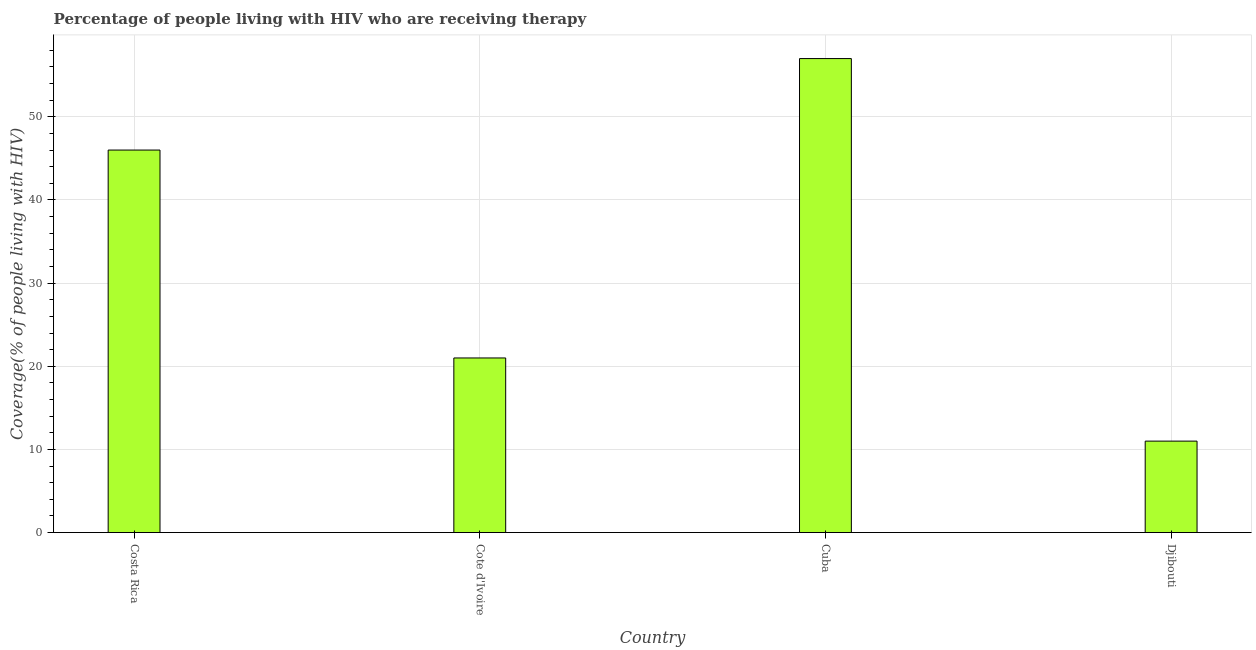Does the graph contain any zero values?
Give a very brief answer. No. Does the graph contain grids?
Your response must be concise. Yes. What is the title of the graph?
Keep it short and to the point. Percentage of people living with HIV who are receiving therapy. What is the label or title of the Y-axis?
Provide a short and direct response. Coverage(% of people living with HIV). What is the antiretroviral therapy coverage in Cote d'Ivoire?
Make the answer very short. 21. Across all countries, what is the maximum antiretroviral therapy coverage?
Give a very brief answer. 57. Across all countries, what is the minimum antiretroviral therapy coverage?
Provide a short and direct response. 11. In which country was the antiretroviral therapy coverage maximum?
Your answer should be very brief. Cuba. In which country was the antiretroviral therapy coverage minimum?
Your answer should be very brief. Djibouti. What is the sum of the antiretroviral therapy coverage?
Keep it short and to the point. 135. What is the difference between the antiretroviral therapy coverage in Cote d'Ivoire and Djibouti?
Offer a very short reply. 10. What is the average antiretroviral therapy coverage per country?
Ensure brevity in your answer.  33.75. What is the median antiretroviral therapy coverage?
Your response must be concise. 33.5. What is the ratio of the antiretroviral therapy coverage in Costa Rica to that in Cote d'Ivoire?
Keep it short and to the point. 2.19. Is the antiretroviral therapy coverage in Costa Rica less than that in Cote d'Ivoire?
Make the answer very short. No. Is the sum of the antiretroviral therapy coverage in Costa Rica and Djibouti greater than the maximum antiretroviral therapy coverage across all countries?
Offer a terse response. No. What is the difference between the highest and the lowest antiretroviral therapy coverage?
Offer a very short reply. 46. How many bars are there?
Offer a terse response. 4. How many countries are there in the graph?
Your answer should be compact. 4. Are the values on the major ticks of Y-axis written in scientific E-notation?
Your answer should be compact. No. What is the Coverage(% of people living with HIV) of Costa Rica?
Provide a succinct answer. 46. What is the Coverage(% of people living with HIV) of Cote d'Ivoire?
Provide a short and direct response. 21. What is the difference between the Coverage(% of people living with HIV) in Costa Rica and Cuba?
Keep it short and to the point. -11. What is the difference between the Coverage(% of people living with HIV) in Cote d'Ivoire and Cuba?
Offer a very short reply. -36. What is the difference between the Coverage(% of people living with HIV) in Cote d'Ivoire and Djibouti?
Provide a succinct answer. 10. What is the ratio of the Coverage(% of people living with HIV) in Costa Rica to that in Cote d'Ivoire?
Your answer should be very brief. 2.19. What is the ratio of the Coverage(% of people living with HIV) in Costa Rica to that in Cuba?
Your answer should be compact. 0.81. What is the ratio of the Coverage(% of people living with HIV) in Costa Rica to that in Djibouti?
Keep it short and to the point. 4.18. What is the ratio of the Coverage(% of people living with HIV) in Cote d'Ivoire to that in Cuba?
Offer a terse response. 0.37. What is the ratio of the Coverage(% of people living with HIV) in Cote d'Ivoire to that in Djibouti?
Ensure brevity in your answer.  1.91. What is the ratio of the Coverage(% of people living with HIV) in Cuba to that in Djibouti?
Your answer should be compact. 5.18. 